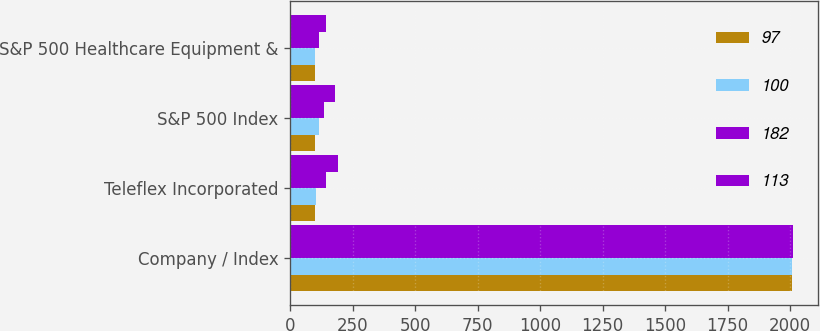Convert chart to OTSL. <chart><loc_0><loc_0><loc_500><loc_500><stacked_bar_chart><ecel><fcel>Company / Index<fcel>Teleflex Incorporated<fcel>S&P 500 Index<fcel>S&P 500 Healthcare Equipment &<nl><fcel>97<fcel>2009<fcel>100<fcel>100<fcel>100<nl><fcel>100<fcel>2010<fcel>102<fcel>115<fcel>97<nl><fcel>182<fcel>2012<fcel>142<fcel>136<fcel>113<nl><fcel>113<fcel>2013<fcel>190<fcel>180<fcel>144<nl></chart> 